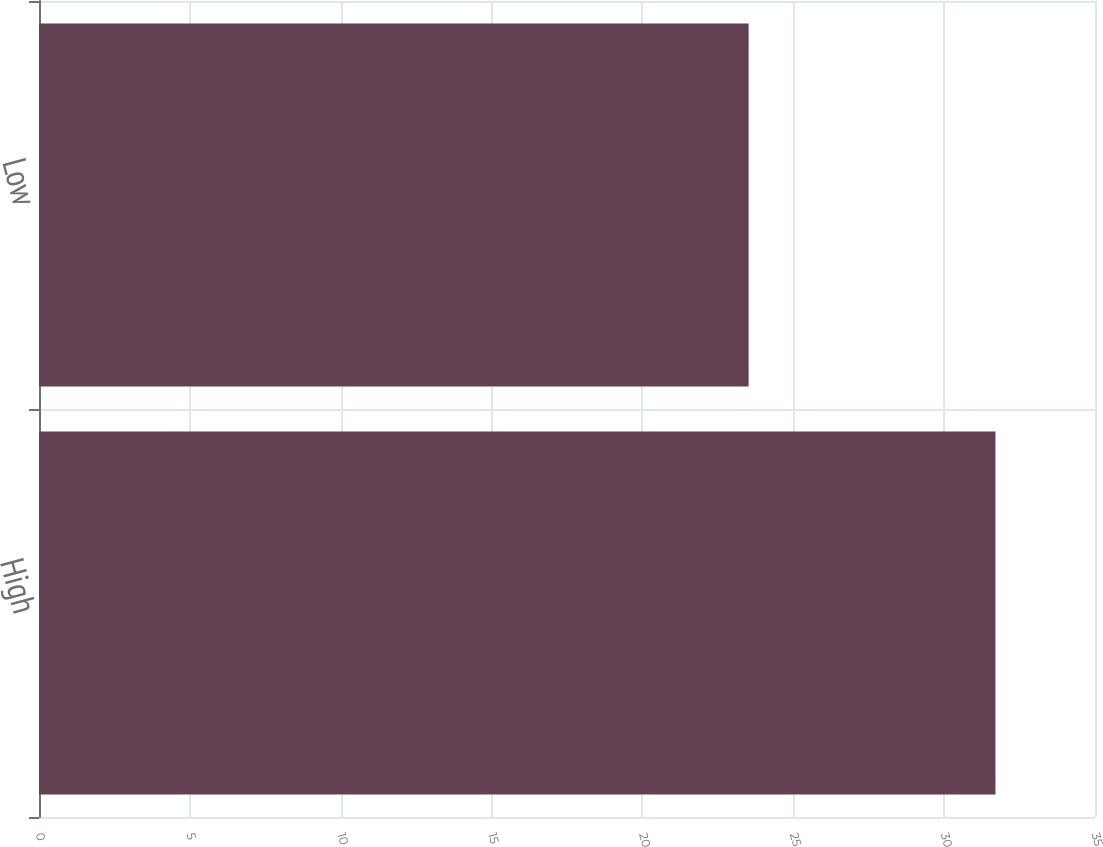Convert chart. <chart><loc_0><loc_0><loc_500><loc_500><bar_chart><fcel>High<fcel>Low<nl><fcel>31.7<fcel>23.52<nl></chart> 